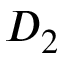<formula> <loc_0><loc_0><loc_500><loc_500>D _ { 2 }</formula> 